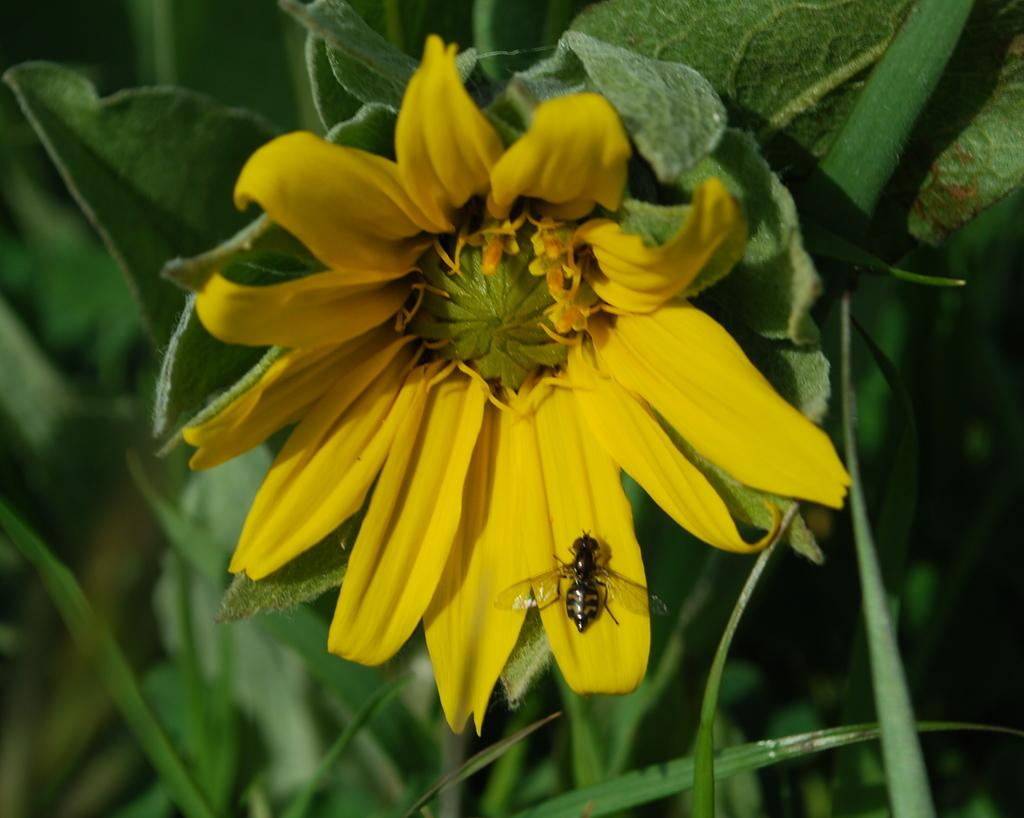What type of flower is present in the image? There is a yellow flower in the image. To which plant does the flower belong? The flower belongs to a plant. Is there any other living organism present on the flower? Yes, there is an insect on the flower. How would you describe the background of the image? The background of the image is blurred. What time of day is it in the image, according to the hour hand on the clock? There is no clock present in the image, so it is not possible to determine the time of day. 